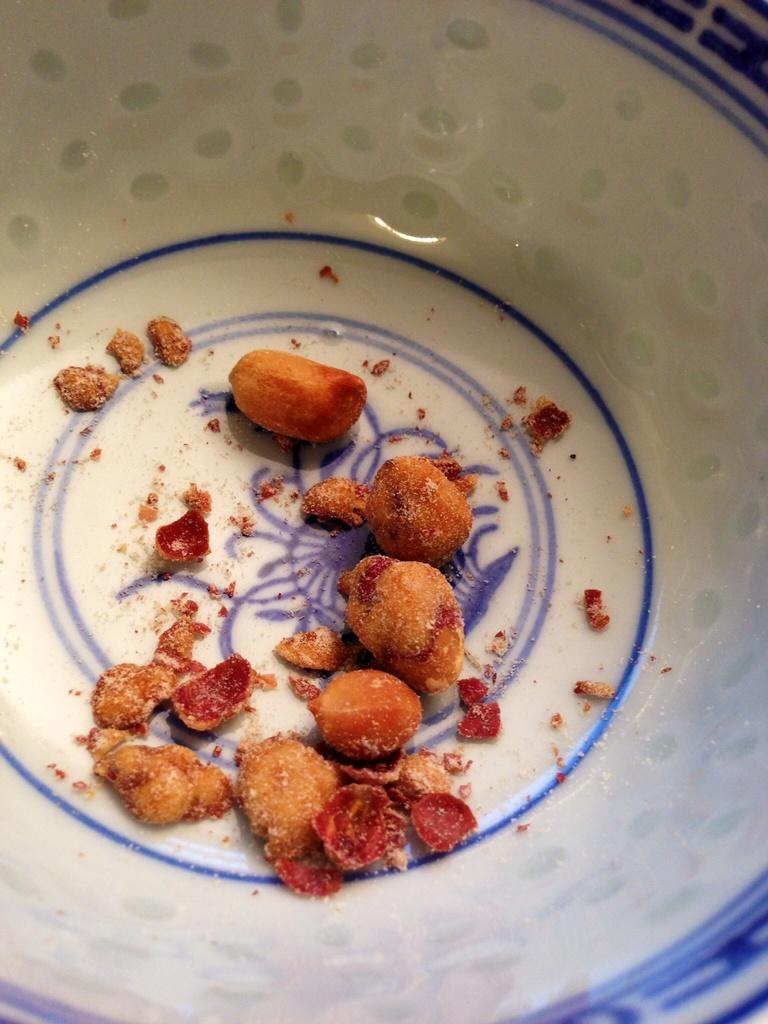What color is the bowl in the image? The bowl in the image is white. What is inside the bowl? The bowl contains a food item. What type of lettuce can be seen in the image? There is no lettuce present in the image. 